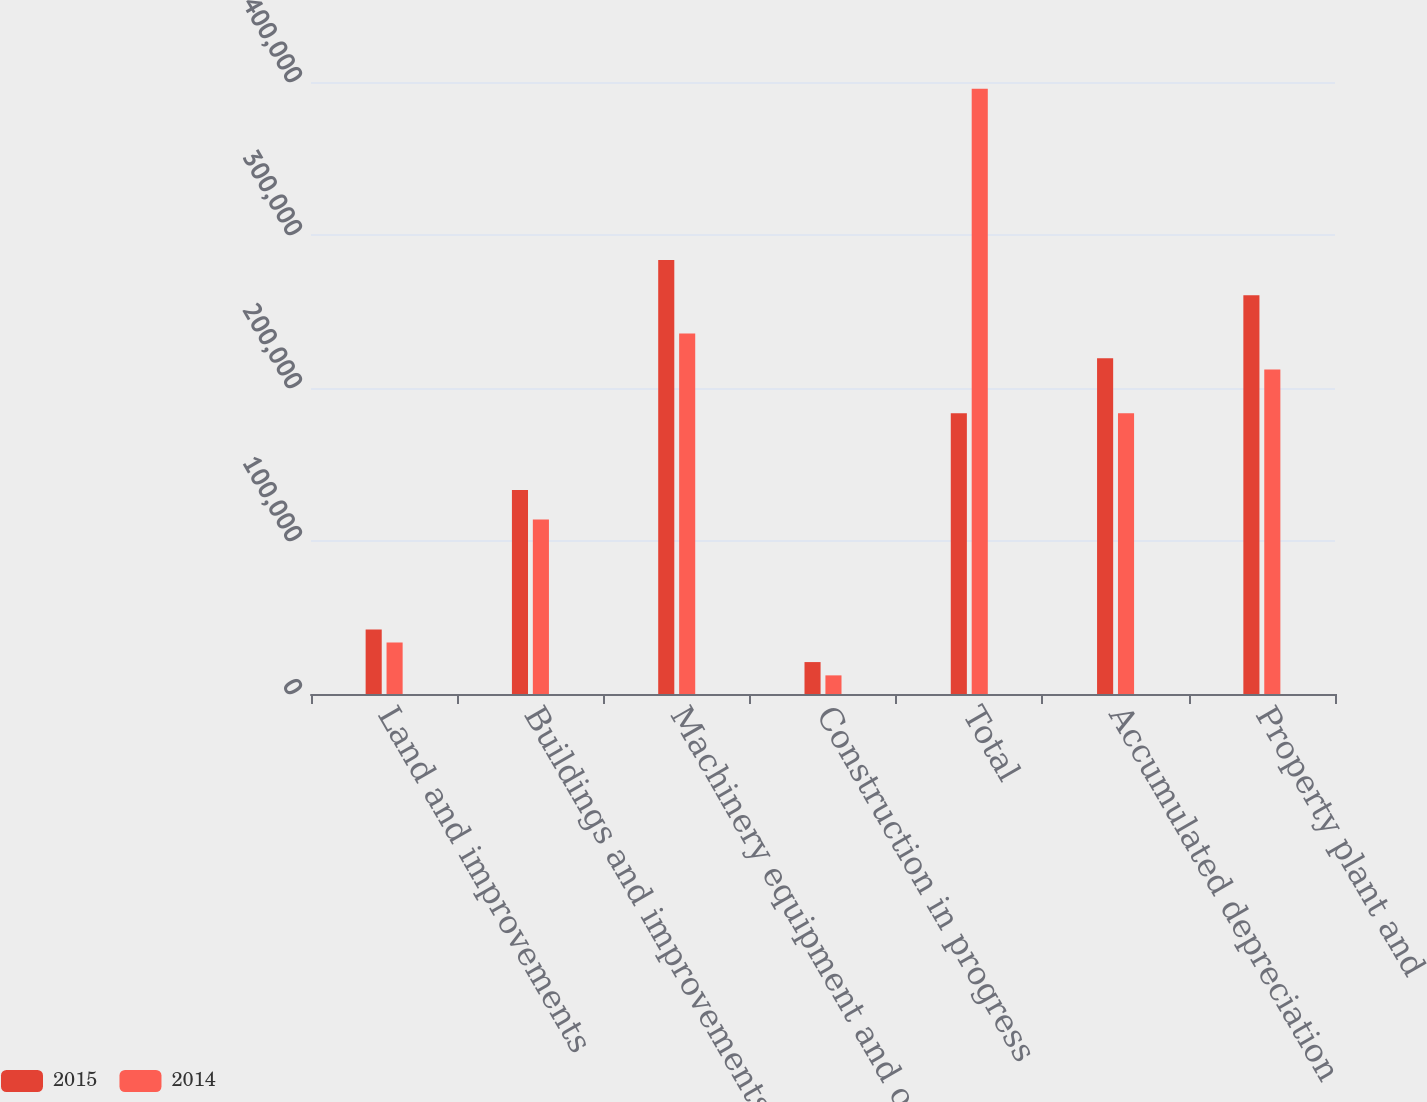Convert chart to OTSL. <chart><loc_0><loc_0><loc_500><loc_500><stacked_bar_chart><ecel><fcel>Land and improvements<fcel>Buildings and improvements<fcel>Machinery equipment and other<fcel>Construction in progress<fcel>Total<fcel>Accumulated depreciation<fcel>Property plant and<nl><fcel>2015<fcel>42235<fcel>133290<fcel>283670<fcel>20867<fcel>183460<fcel>219378<fcel>260684<nl><fcel>2014<fcel>33722<fcel>114030<fcel>235642<fcel>12174<fcel>395568<fcel>183460<fcel>212108<nl></chart> 